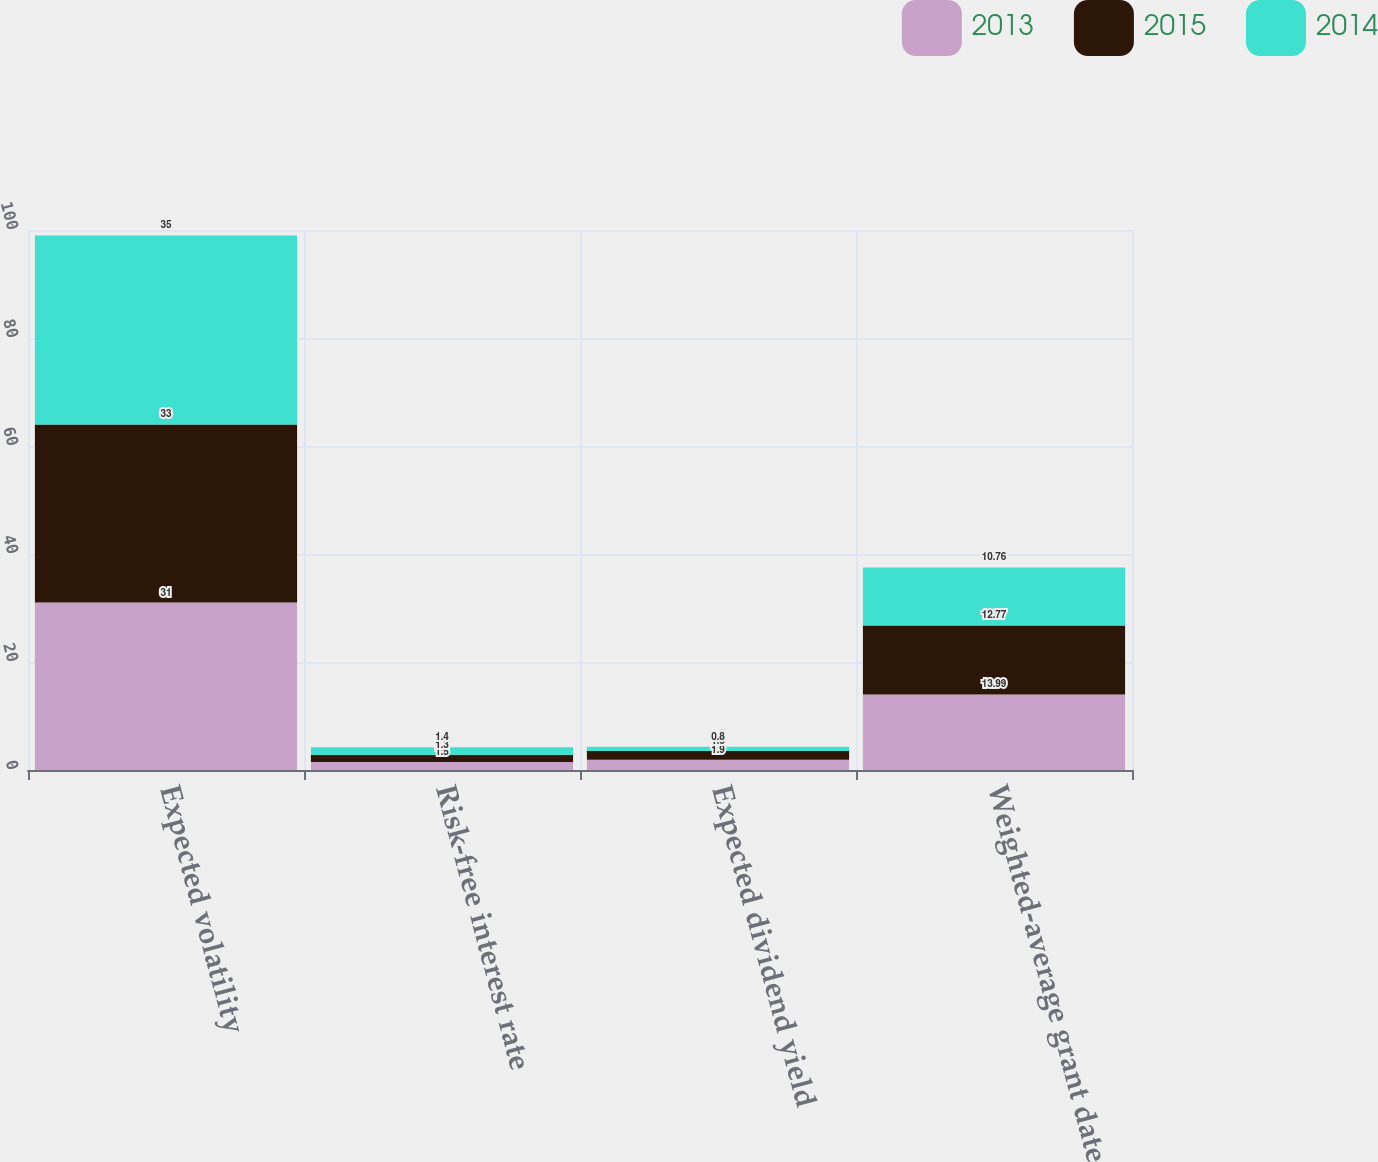Convert chart to OTSL. <chart><loc_0><loc_0><loc_500><loc_500><stacked_bar_chart><ecel><fcel>Expected volatility<fcel>Risk-free interest rate<fcel>Expected dividend yield<fcel>Weighted-average grant date<nl><fcel>2013<fcel>31<fcel>1.5<fcel>1.9<fcel>13.99<nl><fcel>2015<fcel>33<fcel>1.3<fcel>1.6<fcel>12.77<nl><fcel>2014<fcel>35<fcel>1.4<fcel>0.8<fcel>10.76<nl></chart> 